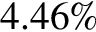<formula> <loc_0><loc_0><loc_500><loc_500>4 . 4 6 \%</formula> 